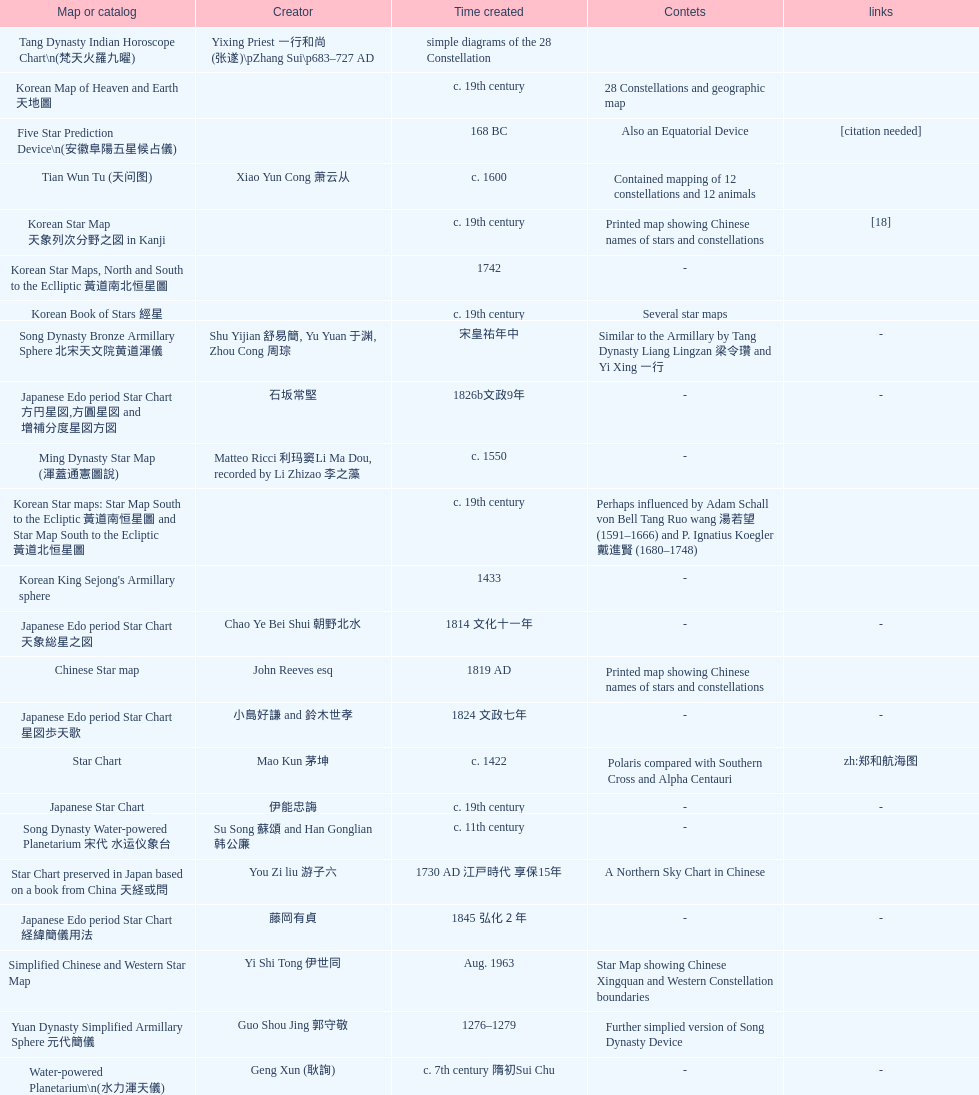What is the name of the oldest map/catalog? M45. 